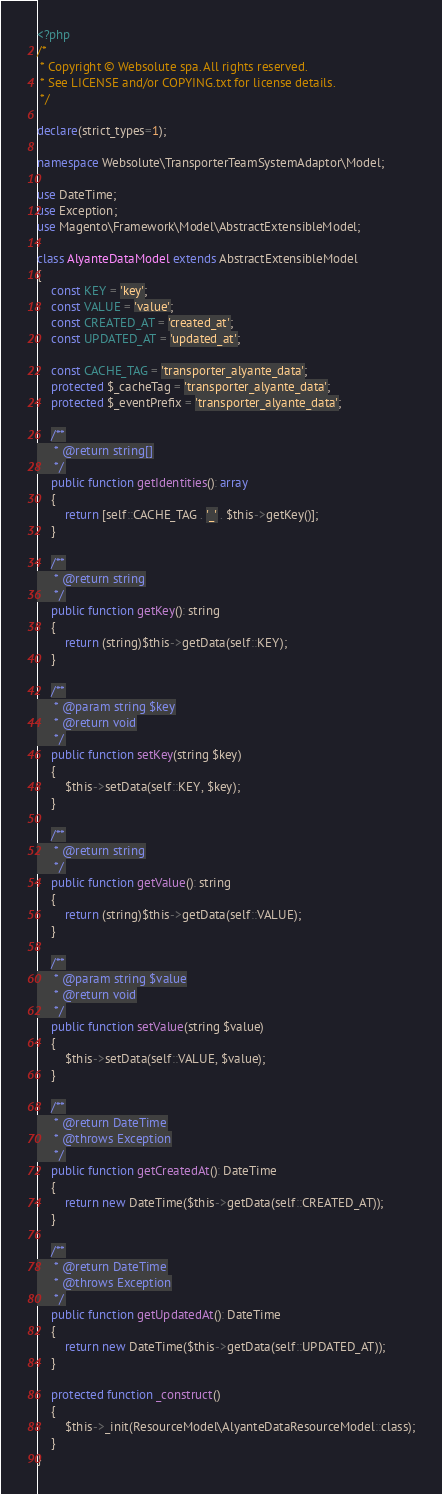<code> <loc_0><loc_0><loc_500><loc_500><_PHP_><?php
/*
 * Copyright © Websolute spa. All rights reserved.
 * See LICENSE and/or COPYING.txt for license details.
 */

declare(strict_types=1);

namespace Websolute\TransporterTeamSystemAdaptor\Model;

use DateTime;
use Exception;
use Magento\Framework\Model\AbstractExtensibleModel;

class AlyanteDataModel extends AbstractExtensibleModel
{
    const KEY = 'key';
    const VALUE = 'value';
    const CREATED_AT = 'created_at';
    const UPDATED_AT = 'updated_at';

    const CACHE_TAG = 'transporter_alyante_data';
    protected $_cacheTag = 'transporter_alyante_data';
    protected $_eventPrefix = 'transporter_alyante_data';

    /**
     * @return string[]
     */
    public function getIdentities(): array
    {
        return [self::CACHE_TAG . '_' . $this->getKey()];
    }

    /**
     * @return string
     */
    public function getKey(): string
    {
        return (string)$this->getData(self::KEY);
    }

    /**
     * @param string $key
     * @return void
     */
    public function setKey(string $key)
    {
        $this->setData(self::KEY, $key);
    }

    /**
     * @return string
     */
    public function getValue(): string
    {
        return (string)$this->getData(self::VALUE);
    }

    /**
     * @param string $value
     * @return void
     */
    public function setValue(string $value)
    {
        $this->setData(self::VALUE, $value);
    }

    /**
     * @return DateTime
     * @throws Exception
     */
    public function getCreatedAt(): DateTime
    {
        return new DateTime($this->getData(self::CREATED_AT));
    }

    /**
     * @return DateTime
     * @throws Exception
     */
    public function getUpdatedAt(): DateTime
    {
        return new DateTime($this->getData(self::UPDATED_AT));
    }

    protected function _construct()
    {
        $this->_init(ResourceModel\AlyanteDataResourceModel::class);
    }
}
</code> 